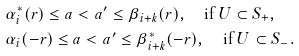Convert formula to latex. <formula><loc_0><loc_0><loc_500><loc_500>& \alpha ^ { * } _ { i } ( r ) \leq a < a ^ { \prime } \leq \beta _ { i + k } ( r ) , \quad \text {if $U \subset S_{+}$} , \\ & \alpha _ { i } ( - r ) \leq a < a ^ { \prime } \leq \beta _ { i + k } ^ { * } ( - r ) , \quad \text {if $U \subset S_{-}$} .</formula> 